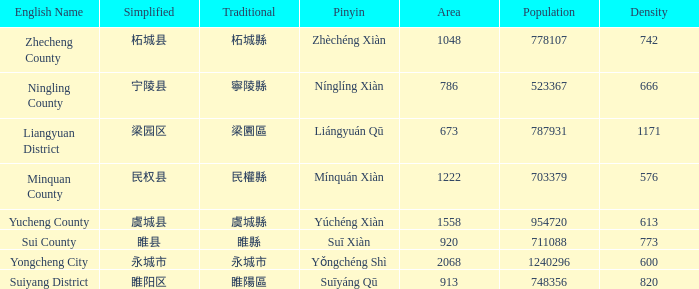What is the traditional form for 宁陵县? 寧陵縣. 